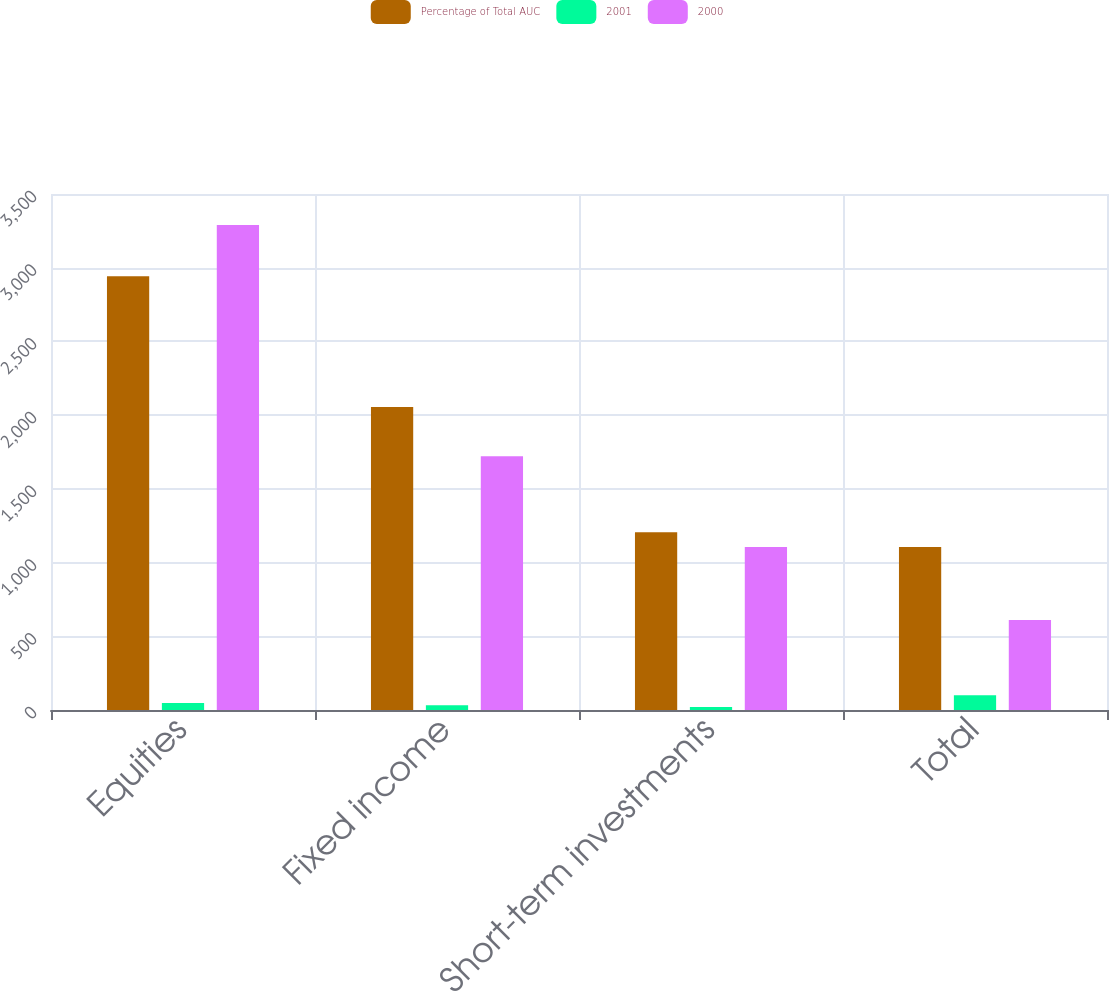Convert chart to OTSL. <chart><loc_0><loc_0><loc_500><loc_500><stacked_bar_chart><ecel><fcel>Equities<fcel>Fixed income<fcel>Short-term investments<fcel>Total<nl><fcel>Percentage of Total AUC<fcel>2942<fcel>2055<fcel>1206<fcel>1106<nl><fcel>2001<fcel>47<fcel>33<fcel>20<fcel>100<nl><fcel>2000<fcel>3290<fcel>1722<fcel>1106<fcel>611<nl></chart> 